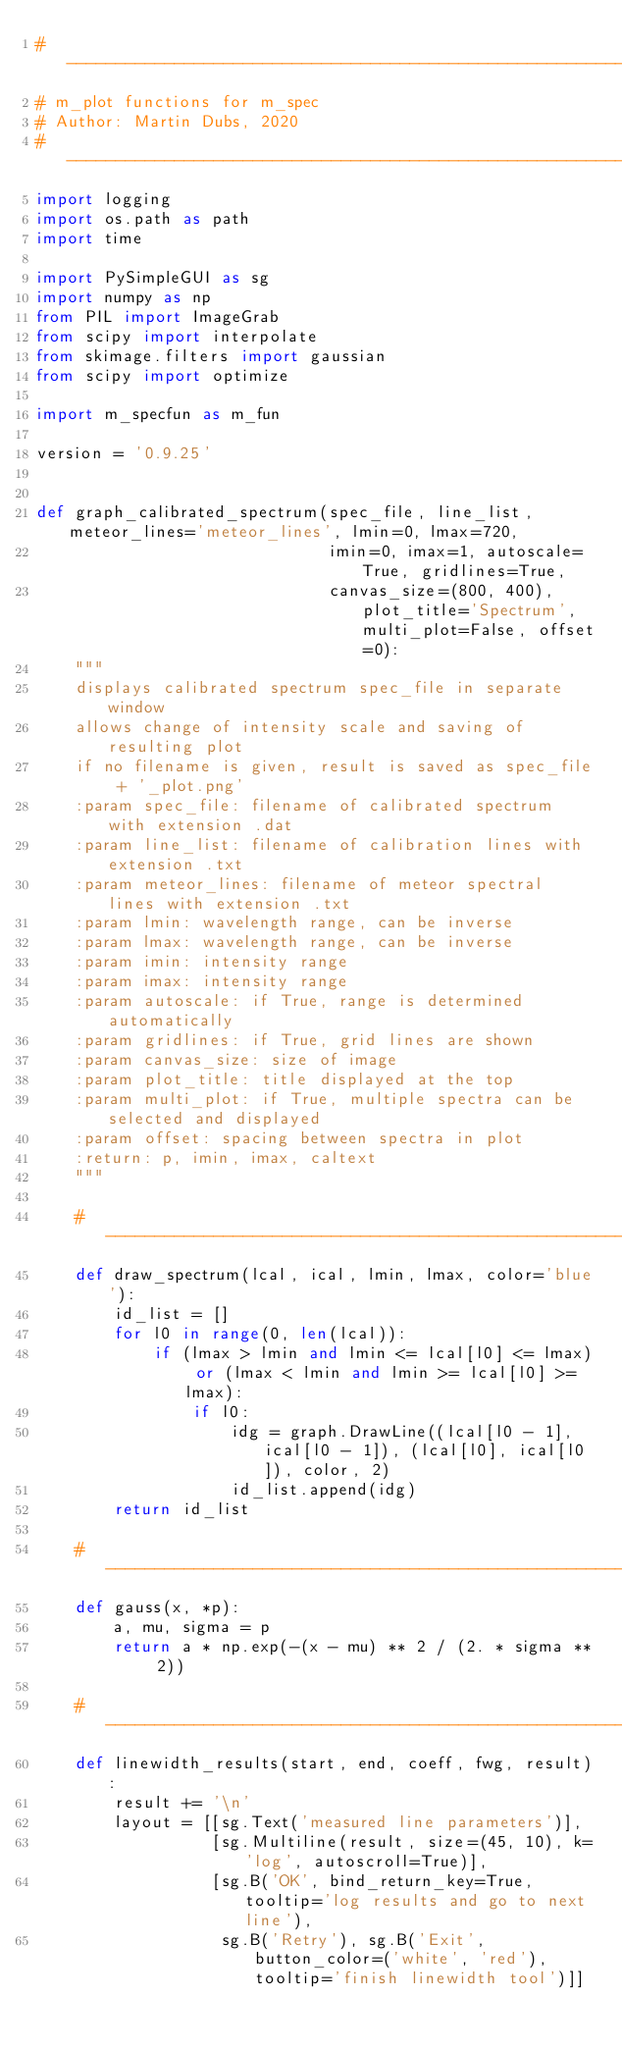Convert code to text. <code><loc_0><loc_0><loc_500><loc_500><_Python_># -------------------------------------------------------------------
# m_plot functions for m_spec
# Author: Martin Dubs, 2020
# -------------------------------------------------------------------
import logging
import os.path as path
import time

import PySimpleGUI as sg
import numpy as np
from PIL import ImageGrab
from scipy import interpolate
from skimage.filters import gaussian
from scipy import optimize

import m_specfun as m_fun

version = '0.9.25'


def graph_calibrated_spectrum(spec_file, line_list, meteor_lines='meteor_lines', lmin=0, lmax=720,
                              imin=0, imax=1, autoscale=True, gridlines=True,
                              canvas_size=(800, 400), plot_title='Spectrum', multi_plot=False, offset=0):
    """
    displays calibrated spectrum spec_file in separate window
    allows change of intensity scale and saving of resulting plot
    if no filename is given, result is saved as spec_file + '_plot.png'
    :param spec_file: filename of calibrated spectrum with extension .dat
    :param line_list: filename of calibration lines with extension .txt
    :param meteor_lines: filename of meteor spectral lines with extension .txt
    :param lmin: wavelength range, can be inverse
    :param lmax: wavelength range, can be inverse
    :param imin: intensity range
    :param imax: intensity range
    :param autoscale: if True, range is determined automatically
    :param gridlines: if True, grid lines are shown
    :param canvas_size: size of image
    :param plot_title: title displayed at the top
    :param multi_plot: if True, multiple spectra can be selected and displayed
    :param offset: spacing between spectra in plot
    :return: p, imin, imax, caltext
    """

    # --------------------------------------------------------------
    def draw_spectrum(lcal, ical, lmin, lmax, color='blue'):
        id_list = []
        for l0 in range(0, len(lcal)):
            if (lmax > lmin and lmin <= lcal[l0] <= lmax) or (lmax < lmin and lmin >= lcal[l0] >= lmax):
                if l0:
                    idg = graph.DrawLine((lcal[l0 - 1], ical[l0 - 1]), (lcal[l0], ical[l0]), color, 2)
                    id_list.append(idg)
        return id_list

    # --------------------------------------------------------------
    def gauss(x, *p):
        a, mu, sigma = p
        return a * np.exp(-(x - mu) ** 2 / (2. * sigma ** 2))

    # --------------------------------------------------------------
    def linewidth_results(start, end, coeff, fwg, result):
        result += '\n'
        layout = [[sg.Text('measured line parameters')],
                  [sg.Multiline(result, size=(45, 10), k='log', autoscroll=True)],
                  [sg.B('OK', bind_return_key=True, tooltip='log results and go to next line'),
                   sg.B('Retry'), sg.B('Exit', button_color=('white', 'red'), tooltip='finish linewidth tool')]]</code> 